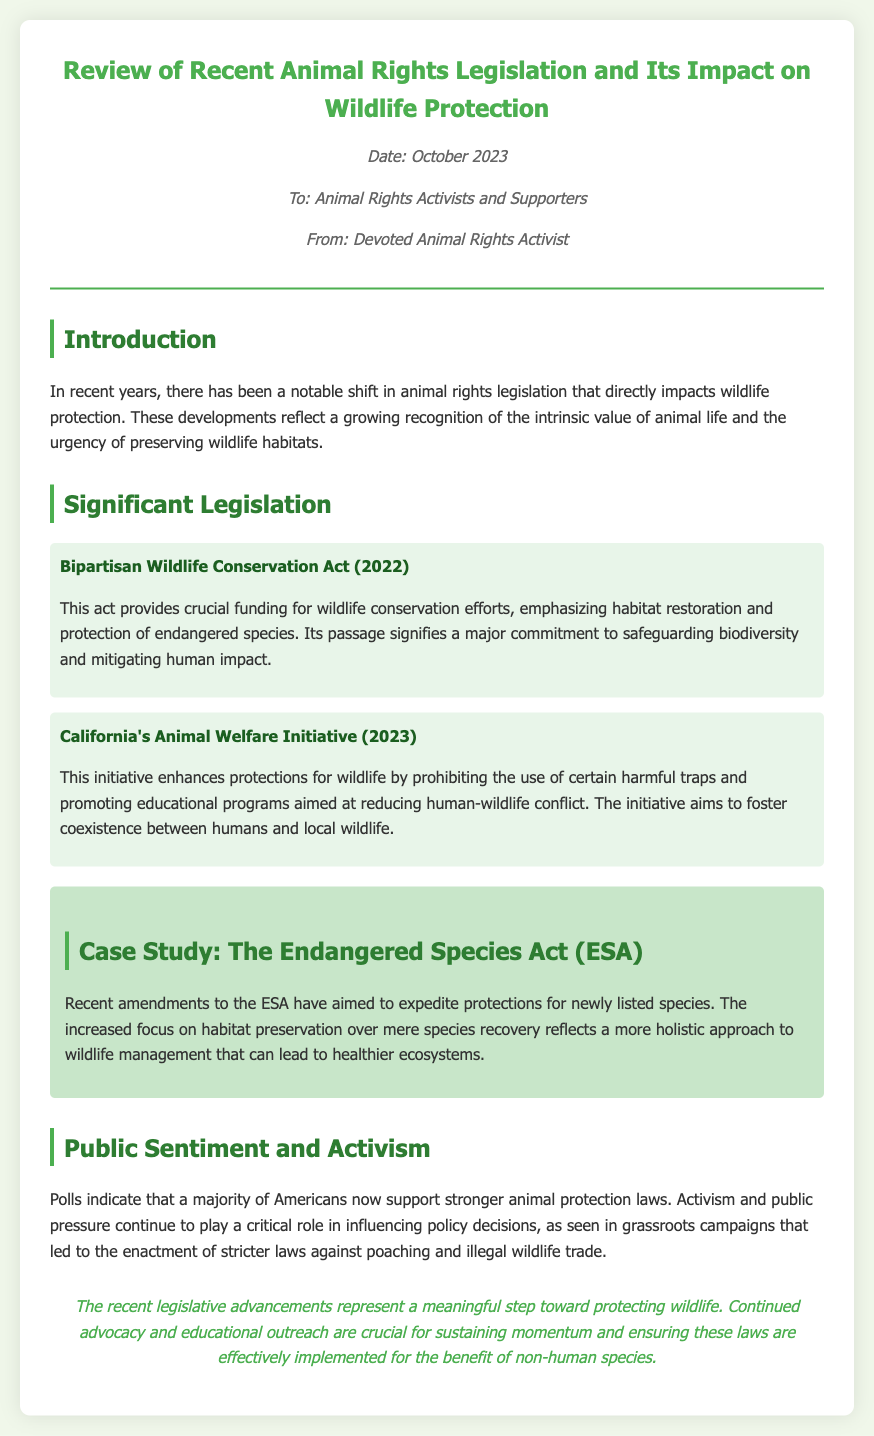What is the date of the memo? The date of the memo is presented in the meta section which shows October 2023.
Answer: October 2023 Who is the recipient of the memo? The memo specifically states that it is addressed to Animal Rights Activists and Supporters.
Answer: Animal Rights Activists and Supporters What significant act was passed in 2022? The significant act mentioned in the document that was passed in 2022 is the Bipartisan Wildlife Conservation Act.
Answer: Bipartisan Wildlife Conservation Act What does California's Animal Welfare Initiative prohibit? The document states that this initiative prohibits the use of certain harmful traps.
Answer: Harmful traps What aspect of wildlife management does the Endangered Species Act amendments focus on? The amendments to the ESA focus on habitat preservation over mere species recovery, indicating a holistic approach.
Answer: Habitat preservation How does public sentiment towards animal protection laws trend according to polls? According to the document, polls indicate that a majority of Americans support stronger animal protection laws.
Answer: Majority support What role does activism play in recent legislative advancements? The document emphasizes that activism and public pressure continue to influence policy decisions significantly.
Answer: Influence policy decisions What is the significance of the recent legislative advancements? The memo concludes that these advancements represent a meaningful step toward protecting wildlife.
Answer: Meaningful step toward protecting wildlife 